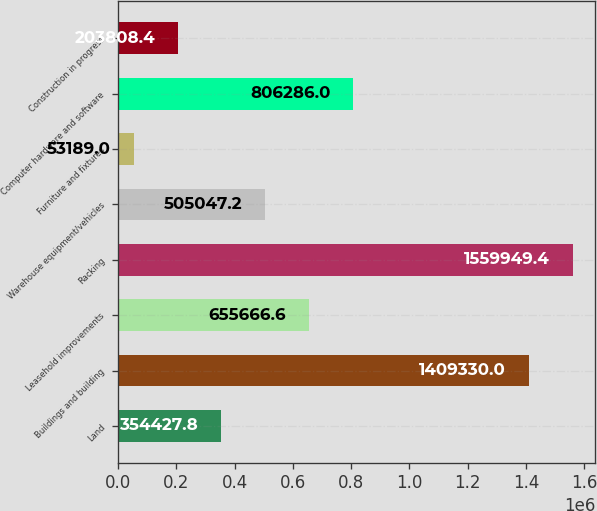<chart> <loc_0><loc_0><loc_500><loc_500><bar_chart><fcel>Land<fcel>Buildings and building<fcel>Leasehold improvements<fcel>Racking<fcel>Warehouse equipment/vehicles<fcel>Furniture and fixtures<fcel>Computer hardware and software<fcel>Construction in progress<nl><fcel>354428<fcel>1.40933e+06<fcel>655667<fcel>1.55995e+06<fcel>505047<fcel>53189<fcel>806286<fcel>203808<nl></chart> 